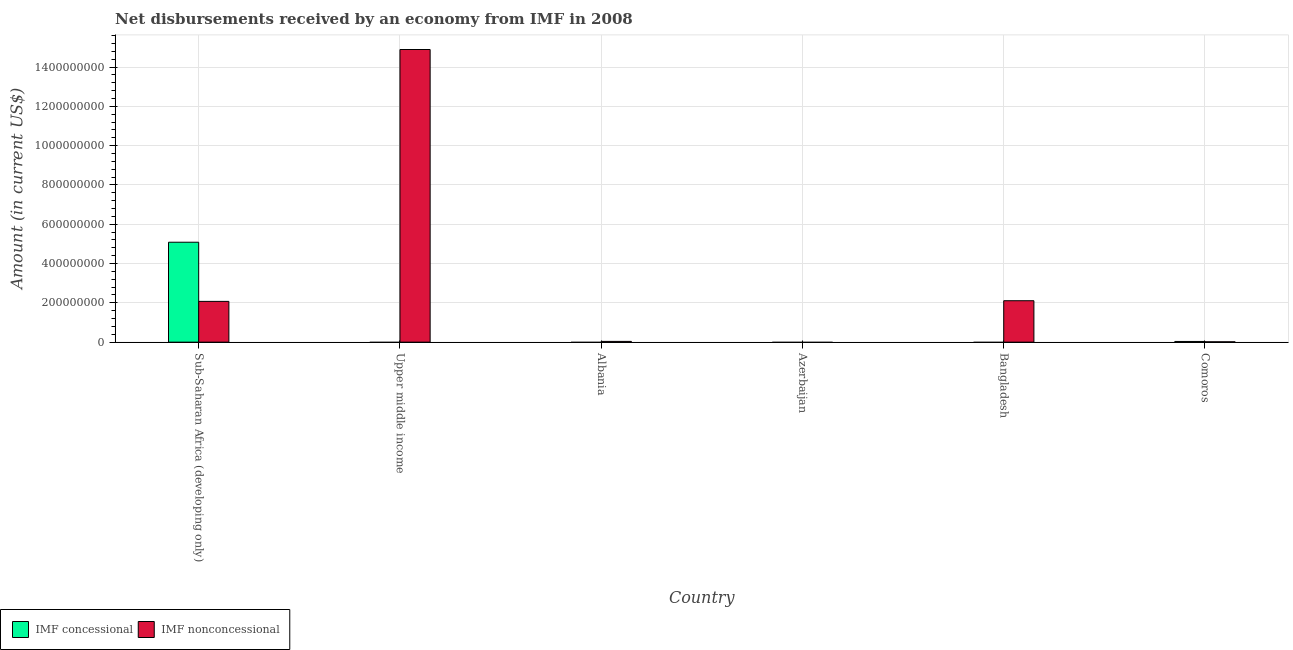Are the number of bars per tick equal to the number of legend labels?
Your answer should be very brief. No. How many bars are there on the 4th tick from the right?
Your response must be concise. 1. What is the label of the 3rd group of bars from the left?
Provide a short and direct response. Albania. In how many cases, is the number of bars for a given country not equal to the number of legend labels?
Keep it short and to the point. 4. What is the net concessional disbursements from imf in Upper middle income?
Offer a very short reply. 0. Across all countries, what is the maximum net concessional disbursements from imf?
Your response must be concise. 5.08e+08. Across all countries, what is the minimum net concessional disbursements from imf?
Keep it short and to the point. 0. In which country was the net non concessional disbursements from imf maximum?
Ensure brevity in your answer.  Upper middle income. What is the total net non concessional disbursements from imf in the graph?
Make the answer very short. 1.91e+09. What is the difference between the net non concessional disbursements from imf in Albania and that in Upper middle income?
Give a very brief answer. -1.49e+09. What is the difference between the net concessional disbursements from imf in Bangladesh and the net non concessional disbursements from imf in Upper middle income?
Provide a short and direct response. -1.49e+09. What is the average net non concessional disbursements from imf per country?
Give a very brief answer. 3.19e+08. What is the difference between the net concessional disbursements from imf and net non concessional disbursements from imf in Comoros?
Offer a very short reply. 1.76e+06. What is the ratio of the net non concessional disbursements from imf in Bangladesh to that in Comoros?
Provide a succinct answer. 119.81. What is the difference between the highest and the second highest net non concessional disbursements from imf?
Make the answer very short. 1.28e+09. What is the difference between the highest and the lowest net concessional disbursements from imf?
Your answer should be very brief. 5.08e+08. In how many countries, is the net concessional disbursements from imf greater than the average net concessional disbursements from imf taken over all countries?
Keep it short and to the point. 1. Is the sum of the net non concessional disbursements from imf in Bangladesh and Sub-Saharan Africa (developing only) greater than the maximum net concessional disbursements from imf across all countries?
Give a very brief answer. No. How many bars are there?
Your response must be concise. 7. How many countries are there in the graph?
Ensure brevity in your answer.  6. What is the difference between two consecutive major ticks on the Y-axis?
Make the answer very short. 2.00e+08. Are the values on the major ticks of Y-axis written in scientific E-notation?
Your answer should be compact. No. Does the graph contain any zero values?
Make the answer very short. Yes. Where does the legend appear in the graph?
Your answer should be very brief. Bottom left. How many legend labels are there?
Provide a short and direct response. 2. What is the title of the graph?
Provide a succinct answer. Net disbursements received by an economy from IMF in 2008. What is the label or title of the X-axis?
Ensure brevity in your answer.  Country. What is the label or title of the Y-axis?
Keep it short and to the point. Amount (in current US$). What is the Amount (in current US$) of IMF concessional in Sub-Saharan Africa (developing only)?
Your response must be concise. 5.08e+08. What is the Amount (in current US$) of IMF nonconcessional in Sub-Saharan Africa (developing only)?
Provide a succinct answer. 2.07e+08. What is the Amount (in current US$) in IMF concessional in Upper middle income?
Your answer should be very brief. 0. What is the Amount (in current US$) of IMF nonconcessional in Upper middle income?
Ensure brevity in your answer.  1.49e+09. What is the Amount (in current US$) in IMF nonconcessional in Albania?
Your response must be concise. 3.85e+06. What is the Amount (in current US$) of IMF concessional in Azerbaijan?
Provide a short and direct response. 0. What is the Amount (in current US$) in IMF nonconcessional in Azerbaijan?
Keep it short and to the point. 0. What is the Amount (in current US$) in IMF nonconcessional in Bangladesh?
Offer a very short reply. 2.11e+08. What is the Amount (in current US$) of IMF concessional in Comoros?
Provide a short and direct response. 3.52e+06. What is the Amount (in current US$) in IMF nonconcessional in Comoros?
Ensure brevity in your answer.  1.76e+06. Across all countries, what is the maximum Amount (in current US$) of IMF concessional?
Your answer should be very brief. 5.08e+08. Across all countries, what is the maximum Amount (in current US$) of IMF nonconcessional?
Keep it short and to the point. 1.49e+09. Across all countries, what is the minimum Amount (in current US$) of IMF nonconcessional?
Provide a short and direct response. 0. What is the total Amount (in current US$) in IMF concessional in the graph?
Make the answer very short. 5.12e+08. What is the total Amount (in current US$) of IMF nonconcessional in the graph?
Your answer should be compact. 1.91e+09. What is the difference between the Amount (in current US$) in IMF nonconcessional in Sub-Saharan Africa (developing only) and that in Upper middle income?
Provide a succinct answer. -1.28e+09. What is the difference between the Amount (in current US$) in IMF nonconcessional in Sub-Saharan Africa (developing only) and that in Albania?
Provide a short and direct response. 2.04e+08. What is the difference between the Amount (in current US$) in IMF nonconcessional in Sub-Saharan Africa (developing only) and that in Bangladesh?
Provide a short and direct response. -3.30e+06. What is the difference between the Amount (in current US$) of IMF concessional in Sub-Saharan Africa (developing only) and that in Comoros?
Provide a short and direct response. 5.05e+08. What is the difference between the Amount (in current US$) in IMF nonconcessional in Sub-Saharan Africa (developing only) and that in Comoros?
Give a very brief answer. 2.06e+08. What is the difference between the Amount (in current US$) of IMF nonconcessional in Upper middle income and that in Albania?
Ensure brevity in your answer.  1.49e+09. What is the difference between the Amount (in current US$) in IMF nonconcessional in Upper middle income and that in Bangladesh?
Your response must be concise. 1.28e+09. What is the difference between the Amount (in current US$) of IMF nonconcessional in Upper middle income and that in Comoros?
Keep it short and to the point. 1.49e+09. What is the difference between the Amount (in current US$) of IMF nonconcessional in Albania and that in Bangladesh?
Ensure brevity in your answer.  -2.07e+08. What is the difference between the Amount (in current US$) of IMF nonconcessional in Albania and that in Comoros?
Ensure brevity in your answer.  2.09e+06. What is the difference between the Amount (in current US$) of IMF nonconcessional in Bangladesh and that in Comoros?
Ensure brevity in your answer.  2.09e+08. What is the difference between the Amount (in current US$) of IMF concessional in Sub-Saharan Africa (developing only) and the Amount (in current US$) of IMF nonconcessional in Upper middle income?
Your answer should be very brief. -9.81e+08. What is the difference between the Amount (in current US$) in IMF concessional in Sub-Saharan Africa (developing only) and the Amount (in current US$) in IMF nonconcessional in Albania?
Provide a succinct answer. 5.05e+08. What is the difference between the Amount (in current US$) of IMF concessional in Sub-Saharan Africa (developing only) and the Amount (in current US$) of IMF nonconcessional in Bangladesh?
Provide a short and direct response. 2.98e+08. What is the difference between the Amount (in current US$) in IMF concessional in Sub-Saharan Africa (developing only) and the Amount (in current US$) in IMF nonconcessional in Comoros?
Your answer should be very brief. 5.07e+08. What is the average Amount (in current US$) in IMF concessional per country?
Keep it short and to the point. 8.53e+07. What is the average Amount (in current US$) in IMF nonconcessional per country?
Give a very brief answer. 3.19e+08. What is the difference between the Amount (in current US$) in IMF concessional and Amount (in current US$) in IMF nonconcessional in Sub-Saharan Africa (developing only)?
Provide a short and direct response. 3.01e+08. What is the difference between the Amount (in current US$) in IMF concessional and Amount (in current US$) in IMF nonconcessional in Comoros?
Provide a short and direct response. 1.76e+06. What is the ratio of the Amount (in current US$) in IMF nonconcessional in Sub-Saharan Africa (developing only) to that in Upper middle income?
Keep it short and to the point. 0.14. What is the ratio of the Amount (in current US$) in IMF nonconcessional in Sub-Saharan Africa (developing only) to that in Albania?
Provide a short and direct response. 53.9. What is the ratio of the Amount (in current US$) in IMF nonconcessional in Sub-Saharan Africa (developing only) to that in Bangladesh?
Make the answer very short. 0.98. What is the ratio of the Amount (in current US$) in IMF concessional in Sub-Saharan Africa (developing only) to that in Comoros?
Your response must be concise. 144.57. What is the ratio of the Amount (in current US$) of IMF nonconcessional in Sub-Saharan Africa (developing only) to that in Comoros?
Ensure brevity in your answer.  117.94. What is the ratio of the Amount (in current US$) of IMF nonconcessional in Upper middle income to that in Albania?
Make the answer very short. 386.88. What is the ratio of the Amount (in current US$) in IMF nonconcessional in Upper middle income to that in Bangladesh?
Offer a terse response. 7.07. What is the ratio of the Amount (in current US$) of IMF nonconcessional in Upper middle income to that in Comoros?
Give a very brief answer. 846.56. What is the ratio of the Amount (in current US$) of IMF nonconcessional in Albania to that in Bangladesh?
Make the answer very short. 0.02. What is the ratio of the Amount (in current US$) in IMF nonconcessional in Albania to that in Comoros?
Provide a short and direct response. 2.19. What is the ratio of the Amount (in current US$) in IMF nonconcessional in Bangladesh to that in Comoros?
Give a very brief answer. 119.81. What is the difference between the highest and the second highest Amount (in current US$) in IMF nonconcessional?
Offer a terse response. 1.28e+09. What is the difference between the highest and the lowest Amount (in current US$) of IMF concessional?
Make the answer very short. 5.08e+08. What is the difference between the highest and the lowest Amount (in current US$) in IMF nonconcessional?
Give a very brief answer. 1.49e+09. 